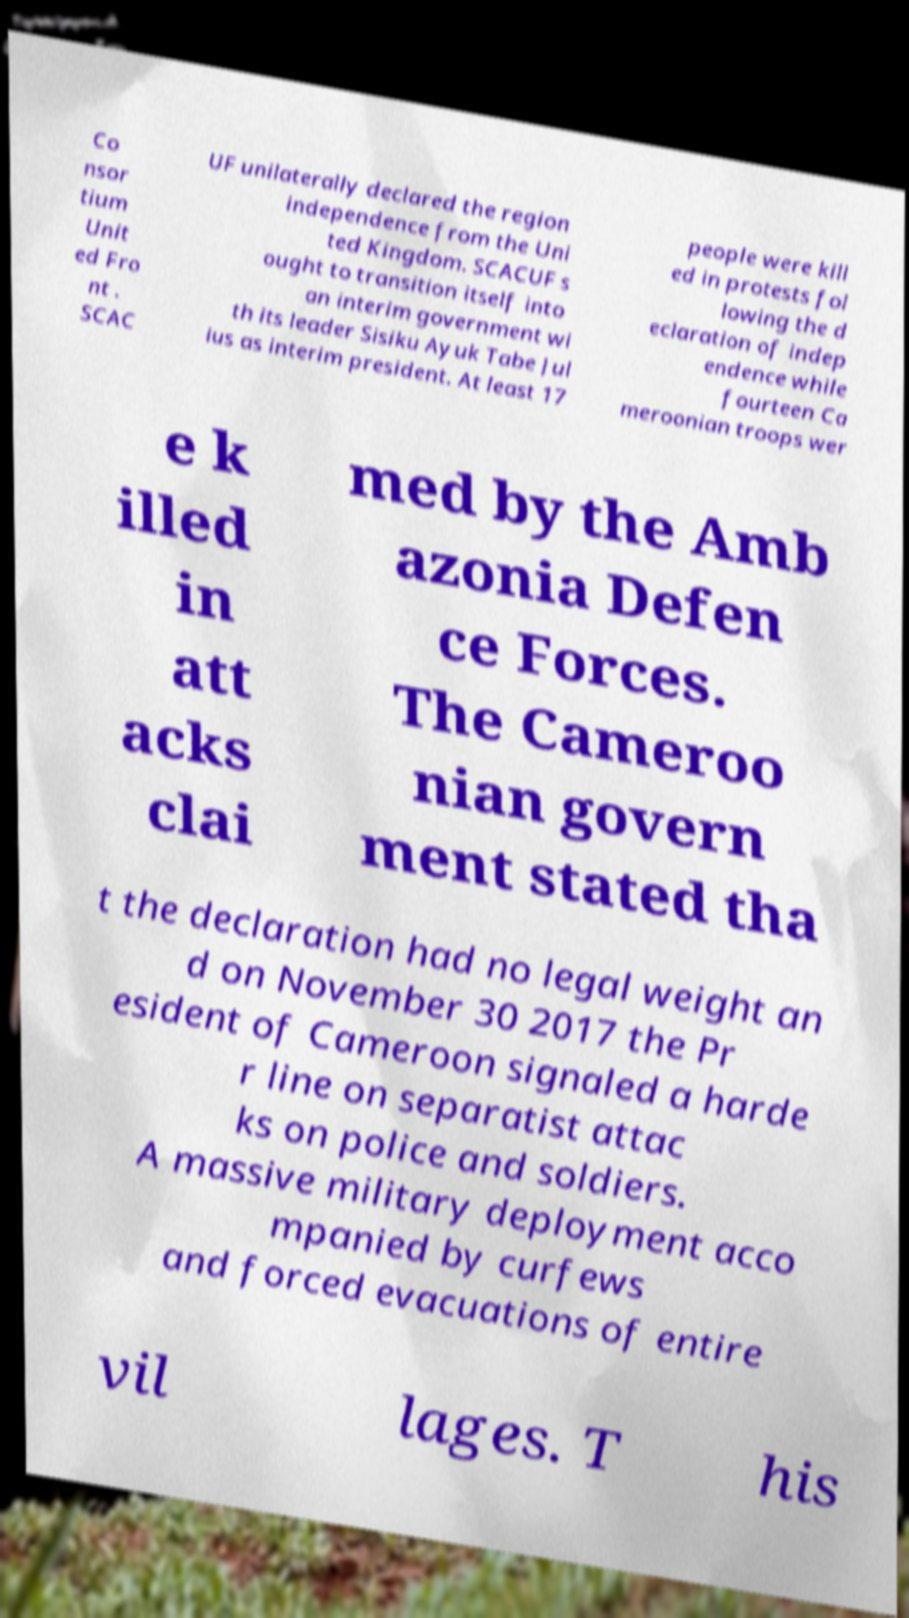What messages or text are displayed in this image? I need them in a readable, typed format. Co nsor tium Unit ed Fro nt . SCAC UF unilaterally declared the region independence from the Uni ted Kingdom. SCACUF s ought to transition itself into an interim government wi th its leader Sisiku Ayuk Tabe Jul ius as interim president. At least 17 people were kill ed in protests fol lowing the d eclaration of indep endence while fourteen Ca meroonian troops wer e k illed in att acks clai med by the Amb azonia Defen ce Forces. The Cameroo nian govern ment stated tha t the declaration had no legal weight an d on November 30 2017 the Pr esident of Cameroon signaled a harde r line on separatist attac ks on police and soldiers. A massive military deployment acco mpanied by curfews and forced evacuations of entire vil lages. T his 